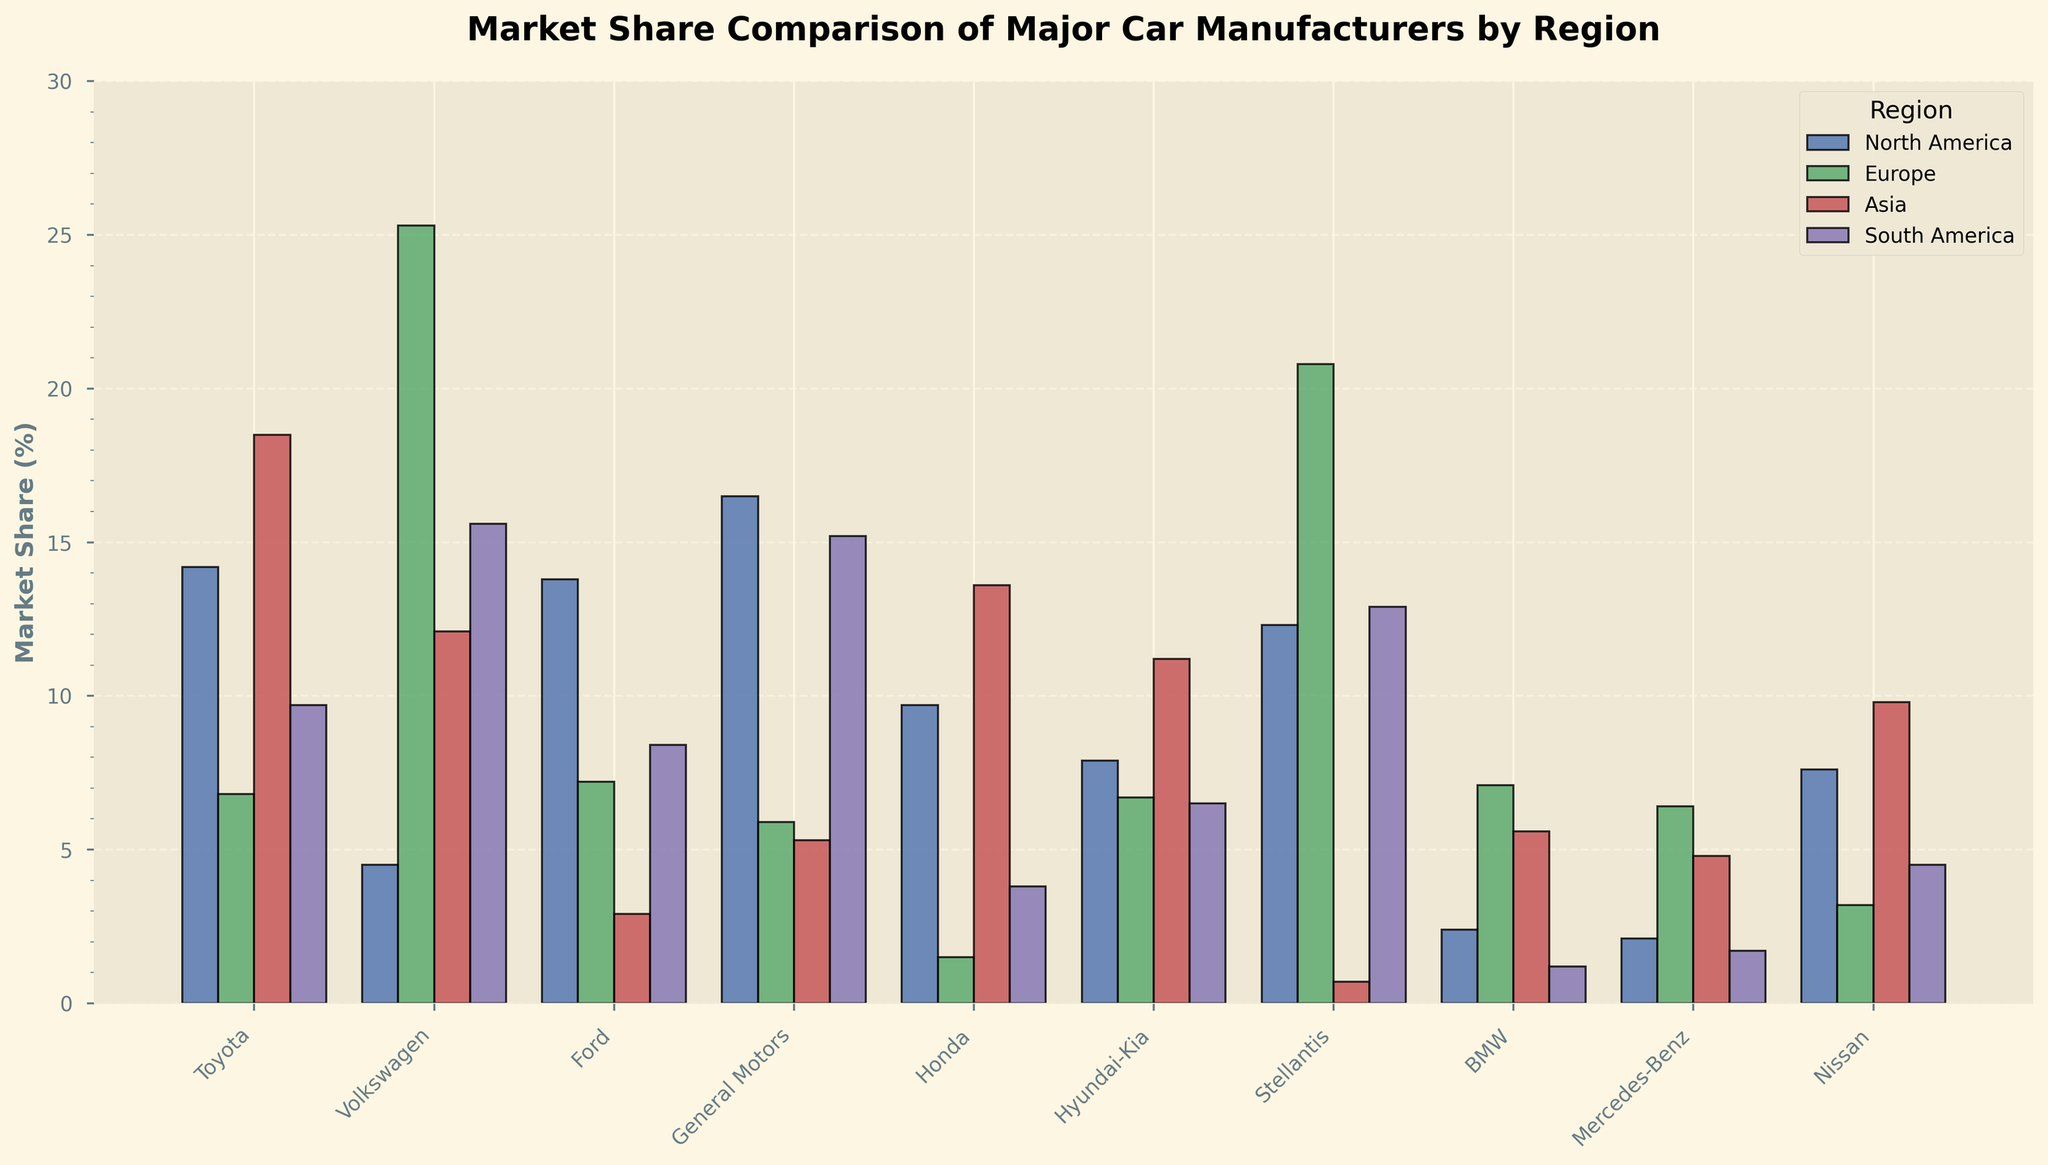Which manufacturer has the highest market share in North America? By observing the heights of the bars representing North America, General Motors has the highest, standing more than 16%.
Answer: General Motors How does Volkswagen's market share in Europe compare to its market share in North America? Compare the heights of the bars representing Europe and North America for Volkswagen. Volkswagen has a much higher market share in Europe (25.3%) than in North America (4.5%).
Answer: Volkswagen's market share in Europe is higher than in North America Which manufacturer has the lowest market share in Asia? By observing the heights of the bars representing Asia, Stellantis has the lowest market share with less than 1%.
Answer: Stellantis What is the average market share of Hyundai-Kia across all regions? Sum the market shares of Hyundai-Kia for North America, Europe, Asia, and South America (7.9% + 6.7% + 11.2% + 6.5% = 32.3%), then divide by 4. The average is 32.3% / 4 = 8.075%.
Answer: 8.075% Compare the market shares of Toyota and Honda in Asia. Which one is higher, and by how much? Toyota's market share in Asia is 18.5% and Honda's is 13.6%. Subtract Honda's share from Toyota's share (18.5% - 13.6% = 4.9%).
Answer: Toyota's is higher by 4.9% Which manufacturers have a market share above 10% in Europe? By observing the heights of the bars representing Europe, Volkswagen (25.3%) and Stellantis (20.8%) have market shares above 10%.
Answer: Volkswagen and Stellantis Which region has the least variation in market shares across all manufacturers? Compare the spread of bar heights across different regions. Asia's bars appear closer in height compared to other regions, indicating less variation.
Answer: Asia Calculate the total market share for General Motors in all regions combined. Sum the market shares of General Motors for North America, Europe, Asia, and South America (16.5% + 5.9% + 5.3% + 15.2% = 42.9%).
Answer: 42.9% What is the difference in market share between the top and bottom manufacturers in South America? The highest market share in South America is by Volkswagen (15.6%), and the lowest is by BMW (1.2%). Subtract BMW's share from Volkswagen's (15.6% - 1.2% = 14.4%).
Answer: 14.4% Which manufacturer has consistent market shares across all regions, and what evidence supports this? Compare the bars' heights for each manufacturer across regions. Hyundai-Kia has fairly consistent heights across all regions (7.9%, 6.7%, 11.2%, 6.5%) with less variation compared to others.
Answer: Hyundai-Kia 